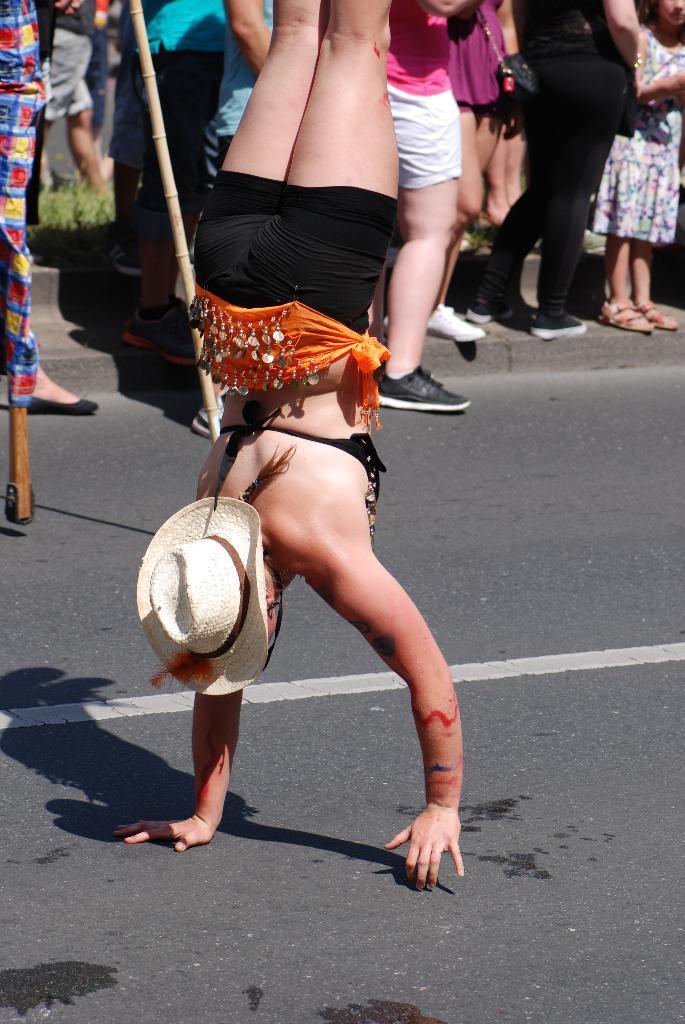How would you summarize this image in a sentence or two? There is a person in black color short, wearing a cap and walking on the hands on the road on which, there is a shadow of this person and there is a white color line. In the background, there are persons and there's grass on the ground. 